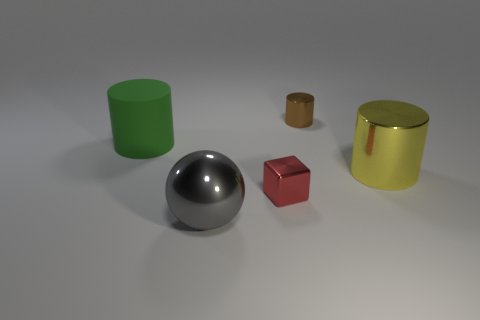Add 5 big spheres. How many objects exist? 10 Subtract all spheres. How many objects are left? 4 Add 3 tiny metallic cylinders. How many tiny metallic cylinders exist? 4 Subtract 0 blue balls. How many objects are left? 5 Subtract all green rubber spheres. Subtract all matte cylinders. How many objects are left? 4 Add 2 large balls. How many large balls are left? 3 